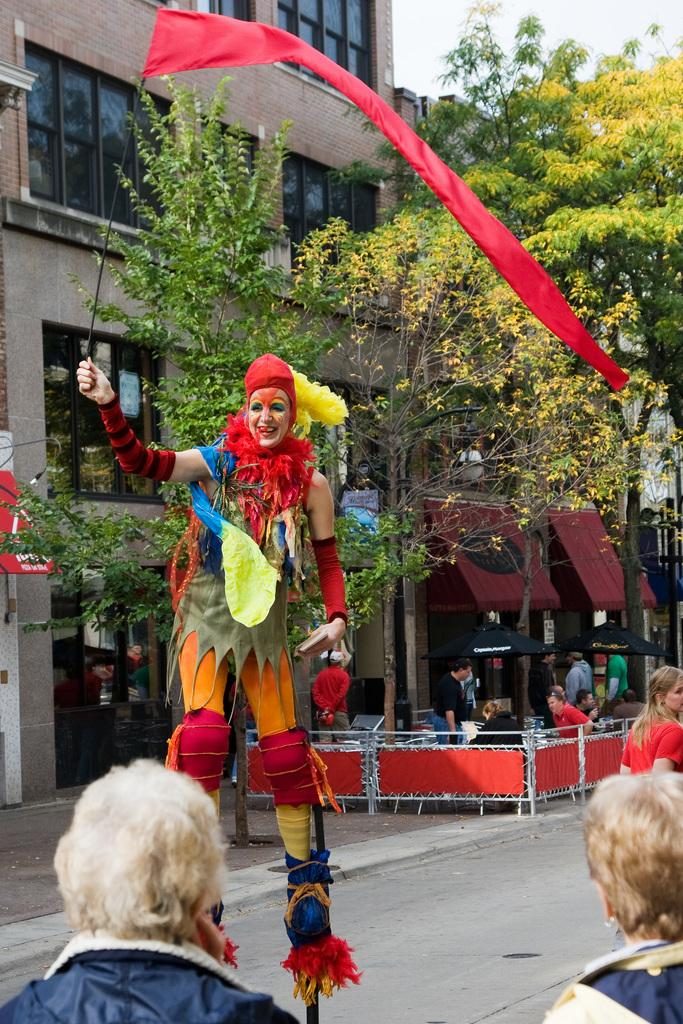What is the woman in the image doing? The woman is standing on poles in the image. What is the woman wearing? The woman is wearing a costume in the image. Are there any spectators in the image? Yes, there are people watching the woman in the image. What can be seen in the background of the image? There are trees and buildings in the background of the image. What type of plantation can be seen in the image? There is no plantation present in the image. What kind of brass instrument is being played by the woman in the image? The woman is not playing any brass instrument in the image; she is standing on poles while wearing a costume. 